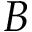Convert formula to latex. <formula><loc_0><loc_0><loc_500><loc_500>B</formula> 